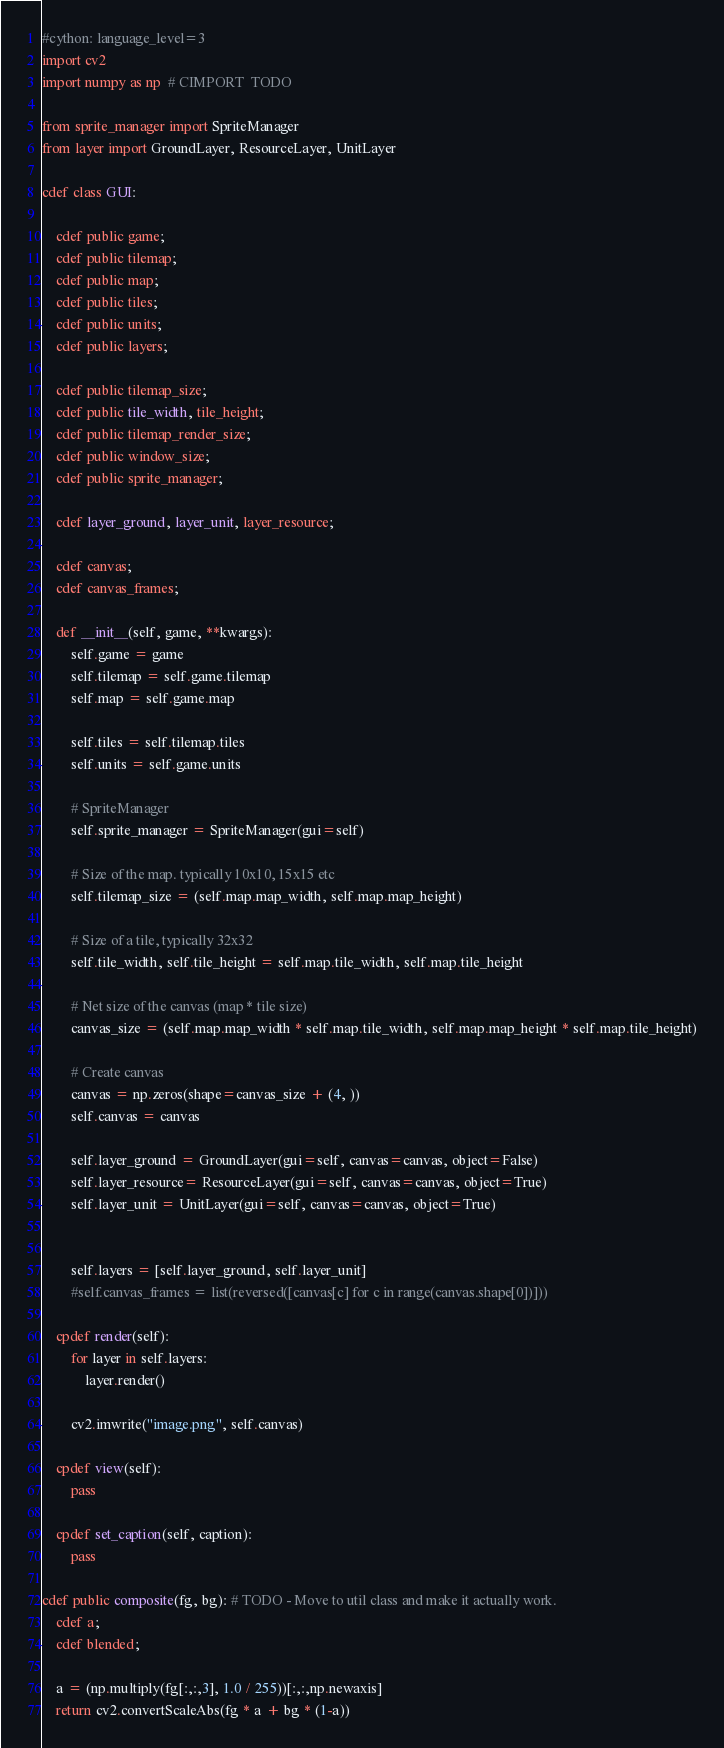<code> <loc_0><loc_0><loc_500><loc_500><_Cython_>#cython: language_level=3
import cv2
import numpy as np  # CIMPORT  TODO

from sprite_manager import SpriteManager
from layer import GroundLayer, ResourceLayer, UnitLayer

cdef class GUI:

    cdef public game;
    cdef public tilemap;
    cdef public map;
    cdef public tiles;
    cdef public units;
    cdef public layers;

    cdef public tilemap_size;
    cdef public tile_width, tile_height;
    cdef public tilemap_render_size;
    cdef public window_size;
    cdef public sprite_manager;

    cdef layer_ground, layer_unit, layer_resource;

    cdef canvas;
    cdef canvas_frames;

    def __init__(self, game, **kwargs):
        self.game = game
        self.tilemap = self.game.tilemap
        self.map = self.game.map

        self.tiles = self.tilemap.tiles
        self.units = self.game.units

        # SpriteManager
        self.sprite_manager = SpriteManager(gui=self)

        # Size of the map. typically 10x10, 15x15 etc
        self.tilemap_size = (self.map.map_width, self.map.map_height)

        # Size of a tile, typically 32x32
        self.tile_width, self.tile_height = self.map.tile_width, self.map.tile_height

        # Net size of the canvas (map * tile size)
        canvas_size = (self.map.map_width * self.map.tile_width, self.map.map_height * self.map.tile_height)

        # Create canvas
        canvas = np.zeros(shape=canvas_size + (4, ))
        self.canvas = canvas

        self.layer_ground = GroundLayer(gui=self, canvas=canvas, object=False)
        self.layer_resource= ResourceLayer(gui=self, canvas=canvas, object=True)
        self.layer_unit = UnitLayer(gui=self, canvas=canvas, object=True)


        self.layers = [self.layer_ground, self.layer_unit]
        #self.canvas_frames = list(reversed([canvas[c] for c in range(canvas.shape[0])]))

    cpdef render(self):
        for layer in self.layers:
            layer.render()

        cv2.imwrite("image.png", self.canvas)

    cpdef view(self):
        pass

    cpdef set_caption(self, caption):
        pass

cdef public composite(fg, bg): # TODO - Move to util class and make it actually work.
    cdef a;
    cdef blended;

    a = (np.multiply(fg[:,:,3], 1.0 / 255))[:,:,np.newaxis]
    return cv2.convertScaleAbs(fg * a + bg * (1-a))
</code> 